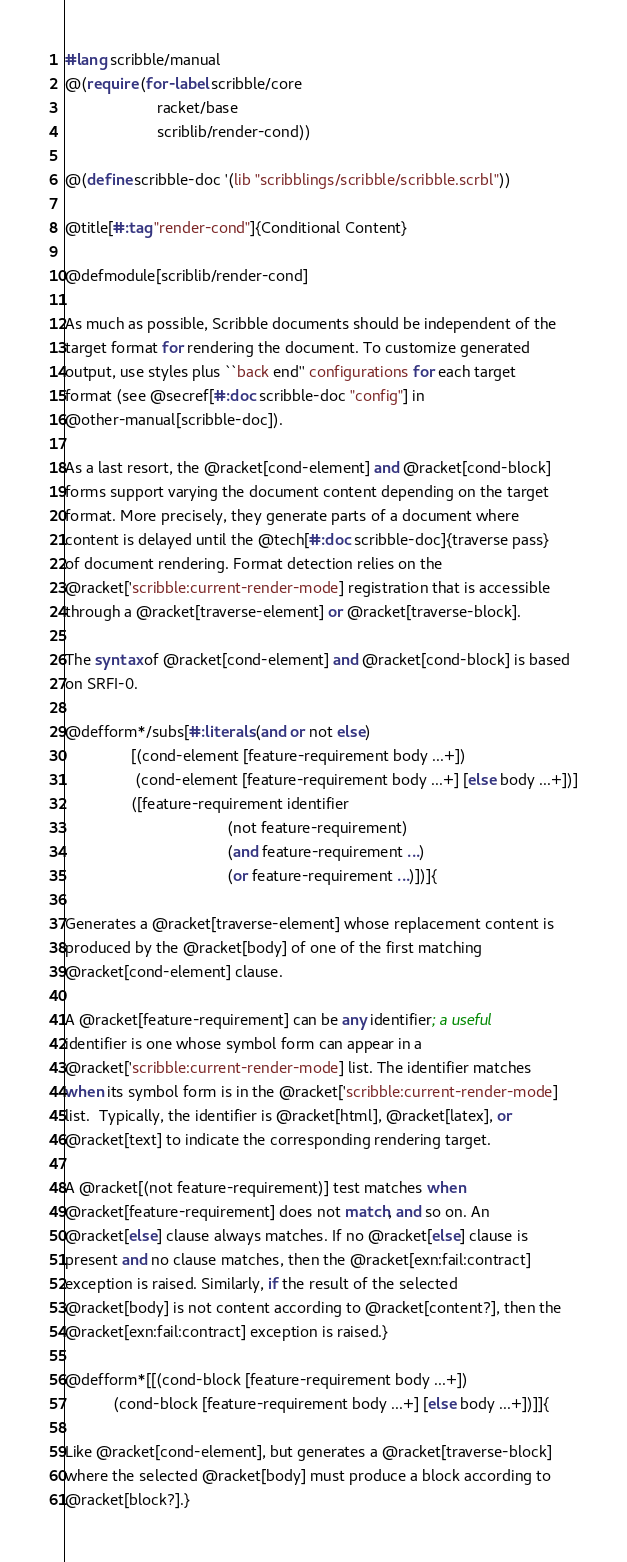Convert code to text. <code><loc_0><loc_0><loc_500><loc_500><_Racket_>#lang scribble/manual
@(require (for-label scribble/core
                     racket/base
                     scriblib/render-cond))

@(define scribble-doc '(lib "scribblings/scribble/scribble.scrbl"))

@title[#:tag "render-cond"]{Conditional Content}

@defmodule[scriblib/render-cond]

As much as possible, Scribble documents should be independent of the
target format for rendering the document. To customize generated
output, use styles plus ``back end'' configurations for each target
format (see @secref[#:doc scribble-doc "config"] in
@other-manual[scribble-doc]).

As a last resort, the @racket[cond-element] and @racket[cond-block]
forms support varying the document content depending on the target
format. More precisely, they generate parts of a document where
content is delayed until the @tech[#:doc scribble-doc]{traverse pass}
of document rendering. Format detection relies on the
@racket['scribble:current-render-mode] registration that is accessible
through a @racket[traverse-element] or @racket[traverse-block].

The syntax of @racket[cond-element] and @racket[cond-block] is based
on SRFI-0.

@defform*/subs[#:literals (and or not else)
               [(cond-element [feature-requirement body ...+])
                (cond-element [feature-requirement body ...+] [else body ...+])]
               ([feature-requirement identifier
                                     (not feature-requirement)
                                     (and feature-requirement ...)
                                     (or feature-requirement ...)])]{

Generates a @racket[traverse-element] whose replacement content is
produced by the @racket[body] of one of the first matching
@racket[cond-element] clause.

A @racket[feature-requirement] can be any identifier; a useful
identifier is one whose symbol form can appear in a
@racket['scribble:current-render-mode] list. The identifier matches
when its symbol form is in the @racket['scribble:current-render-mode]
list.  Typically, the identifier is @racket[html], @racket[latex], or
@racket[text] to indicate the corresponding rendering target.

A @racket[(not feature-requirement)] test matches when
@racket[feature-requirement] does not match, and so on. An
@racket[else] clause always matches. If no @racket[else] clause is
present and no clause matches, then the @racket[exn:fail:contract]
exception is raised. Similarly, if the result of the selected
@racket[body] is not content according to @racket[content?], then the
@racket[exn:fail:contract] exception is raised.}

@defform*[[(cond-block [feature-requirement body ...+])
           (cond-block [feature-requirement body ...+] [else body ...+])]]{

Like @racket[cond-element], but generates a @racket[traverse-block]
where the selected @racket[body] must produce a block according to
@racket[block?].}


</code> 